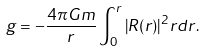<formula> <loc_0><loc_0><loc_500><loc_500>g = - \frac { 4 \pi G m } { r } \int _ { 0 } ^ { r } | R ( r ) | ^ { 2 } r d r .</formula> 